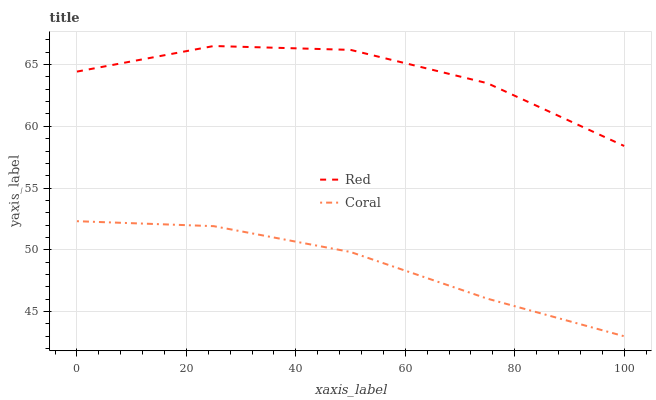Does Coral have the minimum area under the curve?
Answer yes or no. Yes. Does Red have the maximum area under the curve?
Answer yes or no. Yes. Does Red have the minimum area under the curve?
Answer yes or no. No. Is Coral the smoothest?
Answer yes or no. Yes. Is Red the roughest?
Answer yes or no. Yes. Is Red the smoothest?
Answer yes or no. No. Does Coral have the lowest value?
Answer yes or no. Yes. Does Red have the lowest value?
Answer yes or no. No. Does Red have the highest value?
Answer yes or no. Yes. Is Coral less than Red?
Answer yes or no. Yes. Is Red greater than Coral?
Answer yes or no. Yes. Does Coral intersect Red?
Answer yes or no. No. 